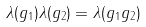<formula> <loc_0><loc_0><loc_500><loc_500>\lambda ( g _ { 1 } ) \lambda ( g _ { 2 } ) = \lambda ( g _ { 1 } g _ { 2 } )</formula> 